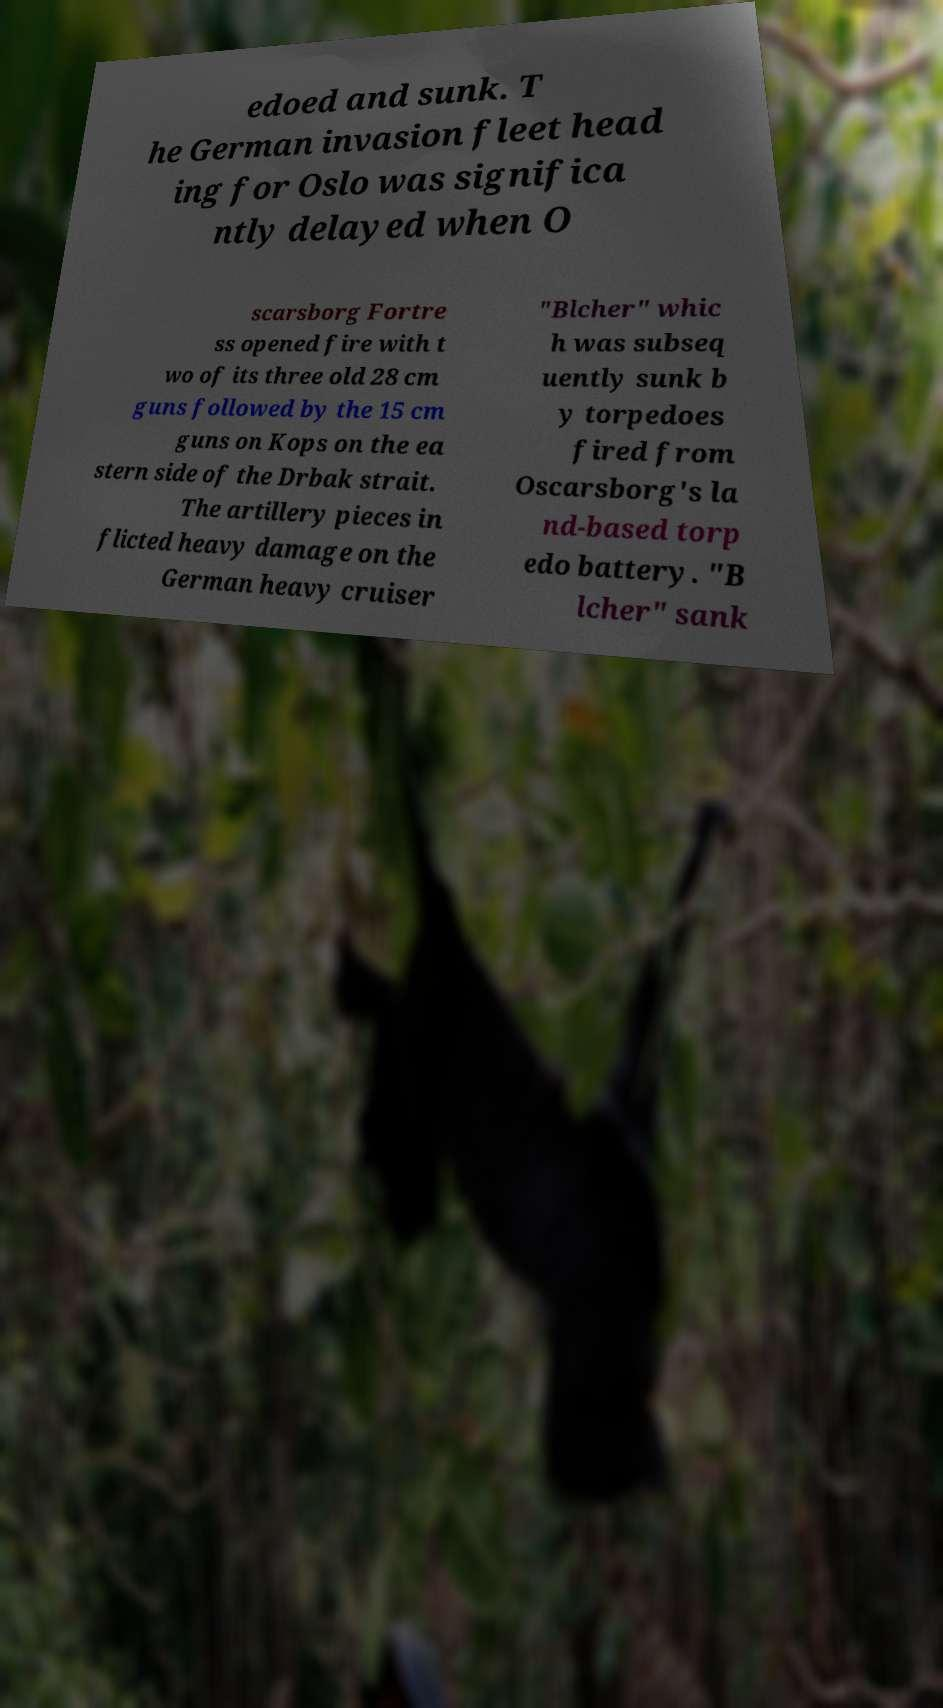Can you read and provide the text displayed in the image?This photo seems to have some interesting text. Can you extract and type it out for me? edoed and sunk. T he German invasion fleet head ing for Oslo was significa ntly delayed when O scarsborg Fortre ss opened fire with t wo of its three old 28 cm guns followed by the 15 cm guns on Kops on the ea stern side of the Drbak strait. The artillery pieces in flicted heavy damage on the German heavy cruiser "Blcher" whic h was subseq uently sunk b y torpedoes fired from Oscarsborg's la nd-based torp edo battery. "B lcher" sank 